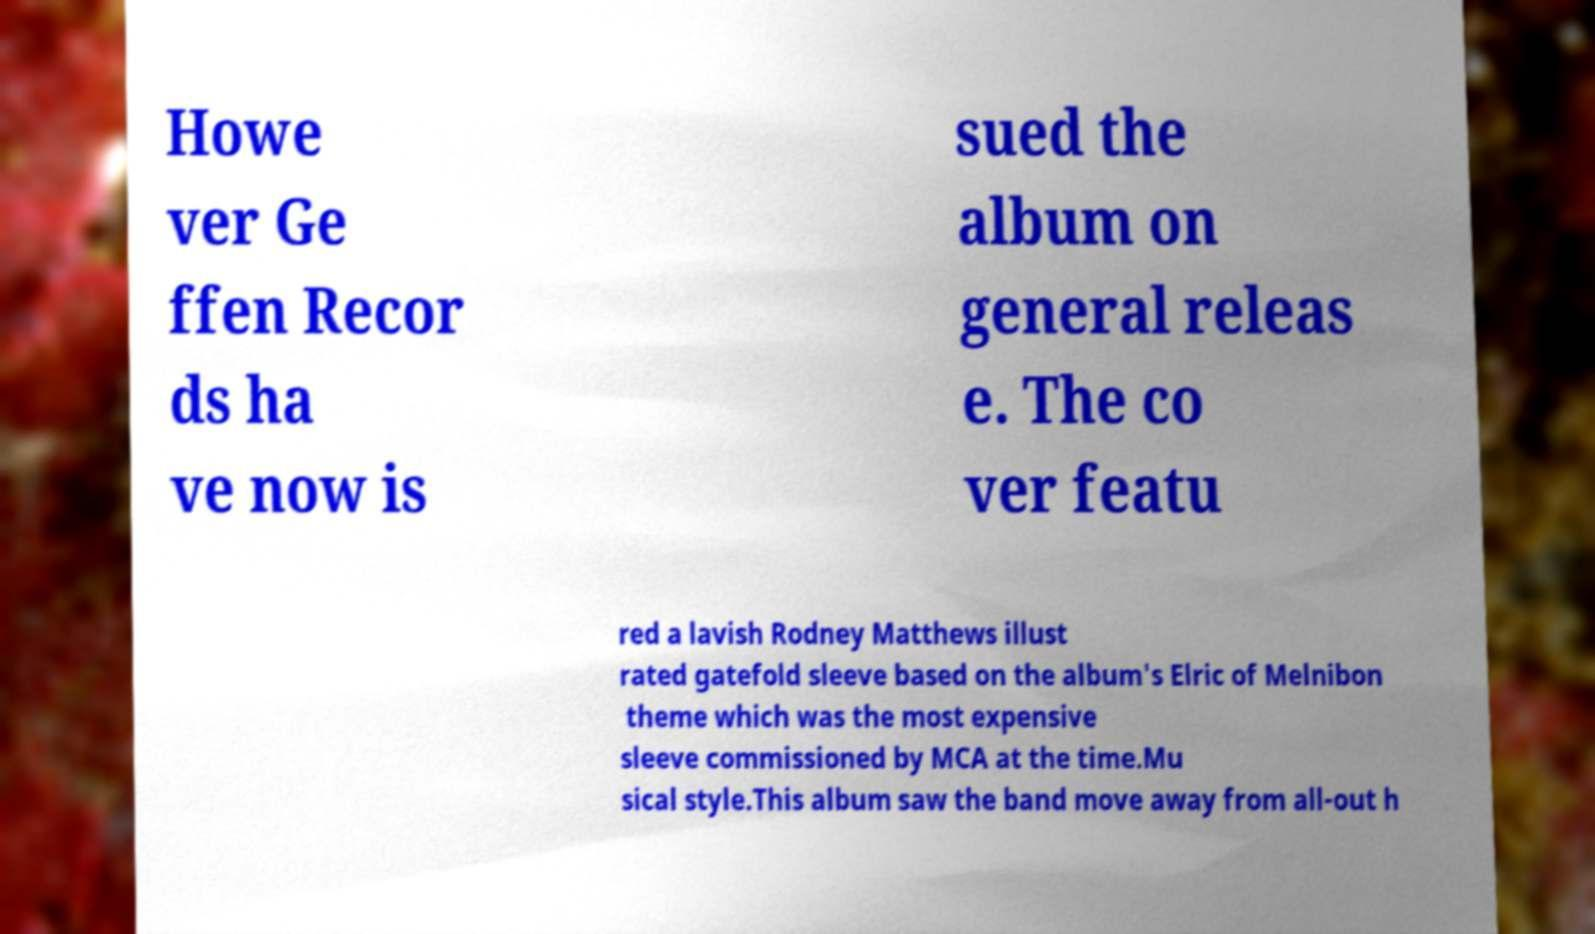Please identify and transcribe the text found in this image. Howe ver Ge ffen Recor ds ha ve now is sued the album on general releas e. The co ver featu red a lavish Rodney Matthews illust rated gatefold sleeve based on the album's Elric of Melnibon theme which was the most expensive sleeve commissioned by MCA at the time.Mu sical style.This album saw the band move away from all-out h 